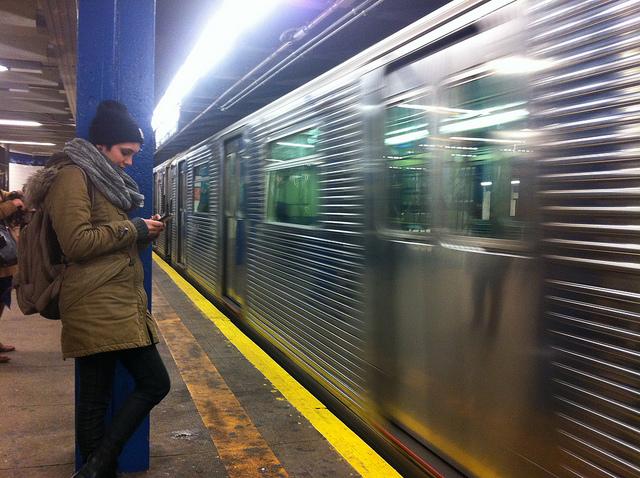What is reflected on the side of the train?
Answer briefly. People. Is the train moving?
Be succinct. Yes. Is the subway crowded?
Answer briefly. No. 